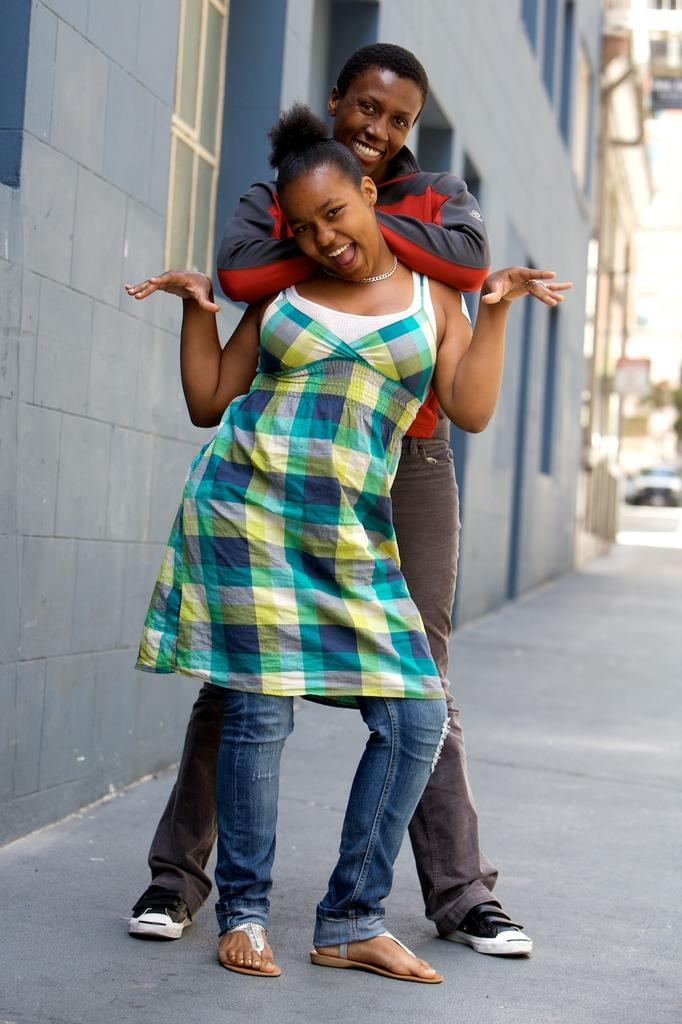How many people are in the image? There are two people in the image, a woman and a man. What are the people in the image doing? Both the woman and the man are standing and smiling. What can be seen in the background of the image? There is a building in the background of the image. Can you describe the building in the image? The building has a wall and a window. What is the condition of the right side of the image? The right side of the image has a blurred view. What type of nerve can be seen in the image? There is no nerve visible in the image. What offer is the man making to the woman in the image? There is no indication of an offer being made in the image; both the woman and the man are simply standing and smiling. 